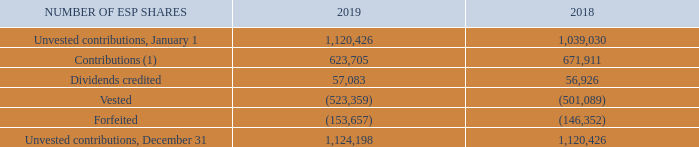DESCRIPTION OF THE PLANS
ESP
The ESP is designed to encourage employees of BCE and its participating subsidiaries to own shares of BCE. Each year, employees can choose to have a certain percentage of their eligible annual earnings withheld through regular payroll deductions for the purchase of BCE common shares. In some cases, the employer also will contribute a percentage of the employee’s eligible annual earnings to the plan, up to a specified maximum. Dividends are credited to the participant’s account on each dividend payment date and are equivalent in value to the dividends paid on BCE common shares.
The ESP allows employees to contribute up to 12% of their annual earnings with a maximum employer contribution of 2%.
Employer contributions to the ESP and related dividends are subject to employees holding their shares for a two-year vesting period.
The trustee of the ESP buys BCE common shares for the participants on the open market, by private purchase or from treasury. BCE determines the method the trustee uses to buy the shares.
At December 31, 2019, 4,360,087 common shares were authorized for issuance from treasury under the ESP.
The following table summarizes the status of unvested employer contributions at December 31, 2019 and 2018.
(1) The weighted average fair value of the shares contributed was $60 in 2019 and $55 in 2018.
What was the number of  Unvested contributions, January 1 for 2019? 1,120,426. What are the conditions regarding employer contributions to the ESP and related dividends? Subject to employees holding their shares for a two-year vesting period. Who can contribute to the ESP? Employees, employer. Which year had a larger amount of dividends credited? 57,083>56,926
Answer: 2019. What is the percentage of unvested contributions on December 31 2019 out of the common shares authorized for issuance from treasury under the ESP?
Answer scale should be: percent. 1,124,198/4,360,087
Answer: 25.78. What is the percentage change in Contributions in 2019?
Answer scale should be: percent. (623,705-671,911)/671,911
Answer: -7.17. 